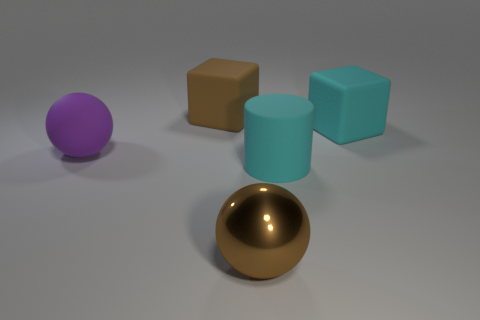Add 3 green cylinders. How many objects exist? 8 Subtract all blocks. How many objects are left? 3 Add 1 shiny things. How many shiny things exist? 2 Subtract 0 yellow cylinders. How many objects are left? 5 Subtract all metallic balls. Subtract all big blue spheres. How many objects are left? 4 Add 5 large brown matte objects. How many large brown matte objects are left? 6 